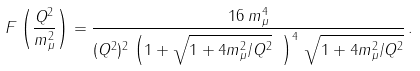Convert formula to latex. <formula><loc_0><loc_0><loc_500><loc_500>F \left ( \frac { Q ^ { 2 } } { m _ { \mu } ^ { 2 } } \right ) = \frac { 1 6 \, m _ { \mu } ^ { 4 } } { ( Q ^ { 2 } ) ^ { 2 } \, \left ( 1 + \sqrt { 1 + 4 m _ { \mu } ^ { 2 } / Q ^ { 2 } } \ \right ) ^ { 4 } \, \sqrt { 1 + 4 m _ { \mu } ^ { 2 } / Q ^ { 2 } } } \, .</formula> 